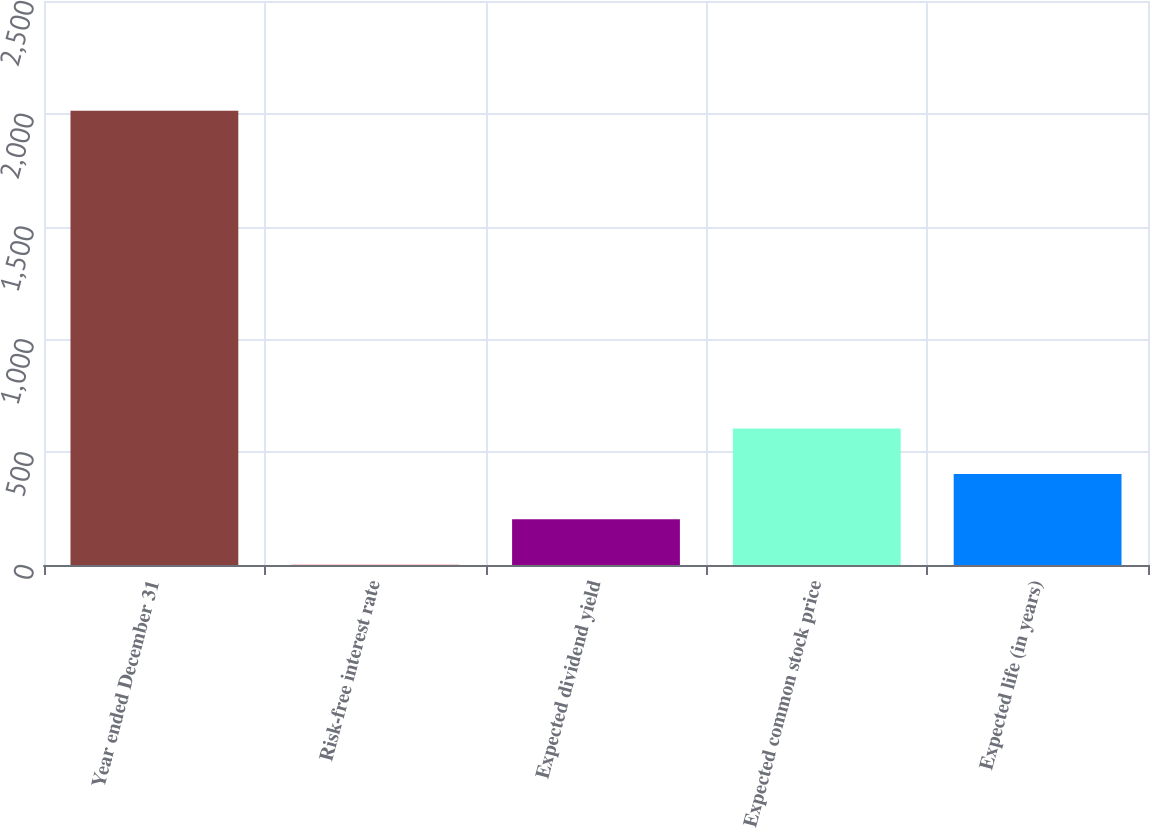Convert chart to OTSL. <chart><loc_0><loc_0><loc_500><loc_500><bar_chart><fcel>Year ended December 31<fcel>Risk-free interest rate<fcel>Expected dividend yield<fcel>Expected common stock price<fcel>Expected life (in years)<nl><fcel>2013<fcel>1.18<fcel>202.36<fcel>604.72<fcel>403.54<nl></chart> 